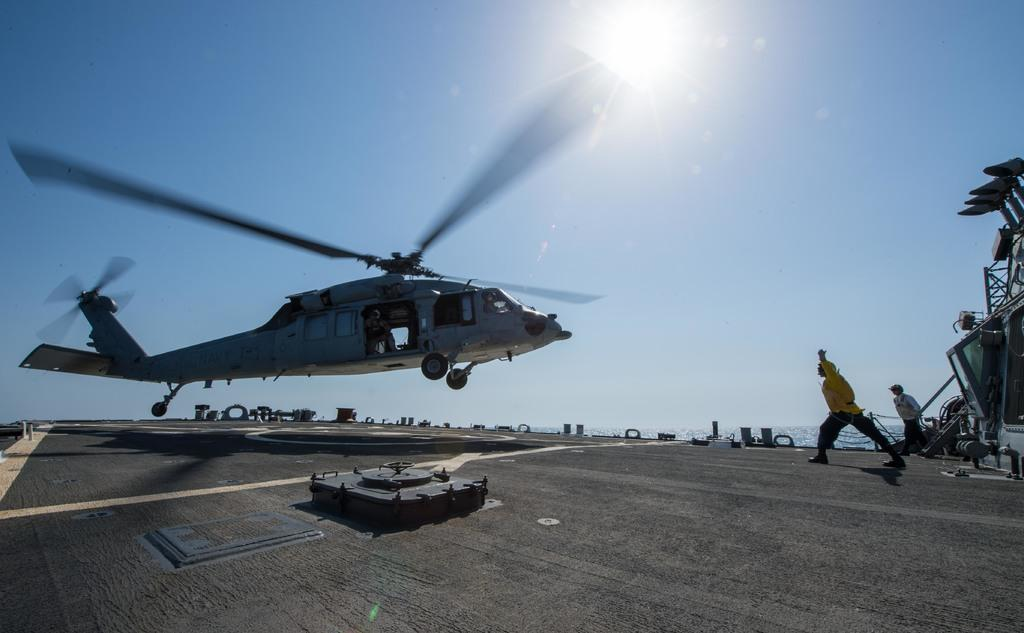How many people can be seen in the image? There are a few people in the image. What type of vehicle is present in the image? There is a helicopter in the image. What is the terrain like in the image? There is ground visible in the image, and there are objects on the ground. Is there any water visible in the image? Yes, there is water visible in the image. What can be seen in the sky in the image? The sky is visible in the image. What is located on the right side of the image? There are objects on the right side of the image. How does the goose stop in the image? There is no goose present in the image, so it cannot stop or be stopped. Is there a horse visible in the image? No, there is no horse visible in the image. 